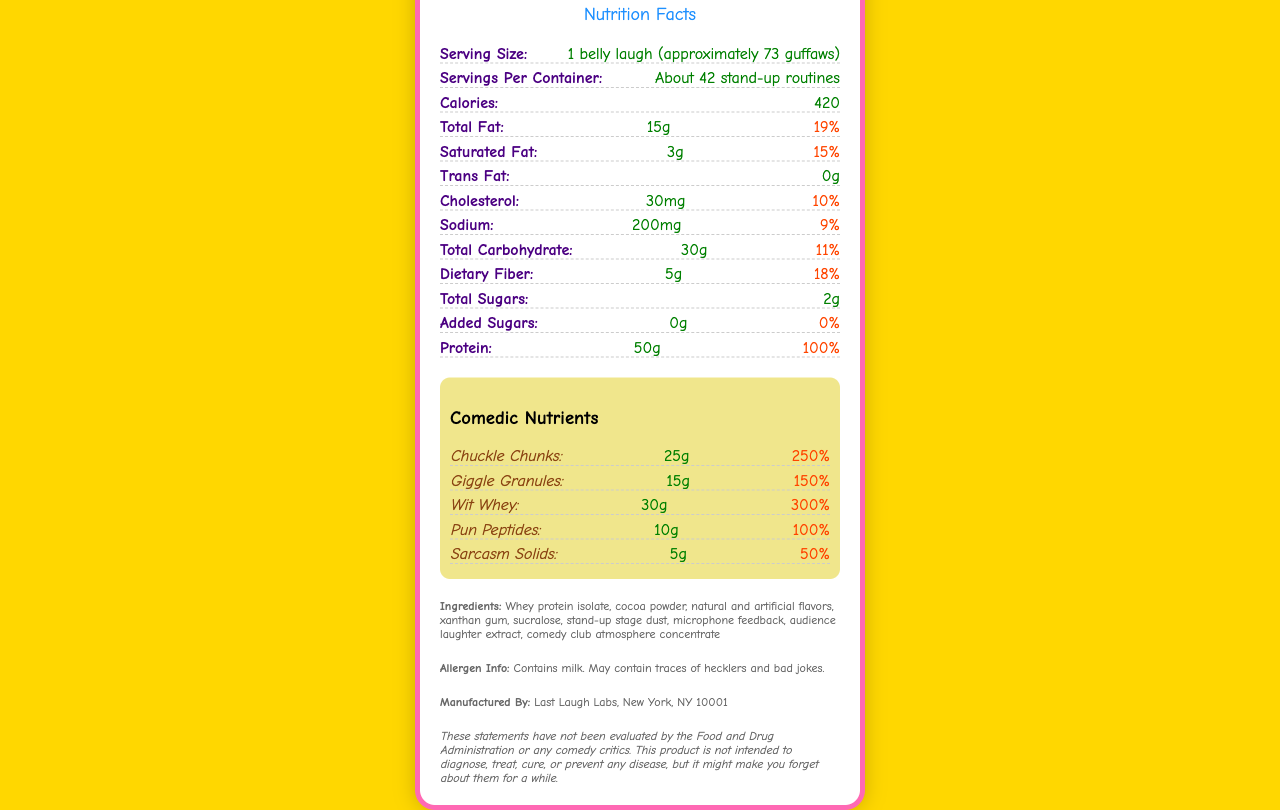What is the serving size for Punchline Protein Powder? The serving size is listed as "1 belly laugh (approximately 73 guffaws)" under the "Serving Size" section of the document.
Answer: 1 belly laugh (approximately 73 guffaws) How many stand-up routines are equivalent to one container of Punchline Protein Powder? According to the "Servings Per Container" section, there are "About 42 stand-up routines" per container.
Answer: About 42 stand-up routines How many calories are in one serving of Punchline Protein Powder? The "Calories" section lists 420 calories per serving.
Answer: 420 calories What is the amount of Chuckle Chunks per serving, and what is its daily value percentage? The "Comedic Nutrients" section specifies 25g of Chuckle Chunks with a daily value of 250%.
Answer: 25g, 250% How much protein does one serving provide? The "Protein" section indicates that one serving provides 50g of protein.
Answer: 50g What is the percentage daily value of iron provided per serving? The document states that the daily value of iron is 45% per serving.
Answer: 45% What allergens are mentioned for Punchline Protein Powder? The "Allergen Info" section indicates that it contains milk and may contain traces of hecklers and bad jokes.
Answer: Contains milk. May contain traces of hecklers and bad jokes. Which of the following is NOT a comedic nutrient found in Punchline Protein Powder? A. Chuckle Chunks B. Wit Whey C. Laugh Loops D. Pun Peptides The "Comedic Nutrients" section lists "Chuckle Chunks," "Wit Whey," and "Pun Peptides," but does not mention "Laugh Loops."
Answer: C. Laugh Loops How many grams of dietary fiber are included in one serving? The "Dietary Fiber" section lists 5 grams per serving.
Answer: 5g What is the percentage daily value of Vitamin D per serving? The information on the percentage daily value for Vitamin D per serving is provided as 10%.
Answer: 10% True or False: Punchline Protein Powder contains added sugars. The document states that the amount of added sugars is 0g, and the daily value is also 0%.
Answer: False Summarize the main idea of the Punchline Protein Powder Nutrition Facts Label. The document details the nutritional information for Punchline Protein Powder, highlighting its comedic branding with unique nutrient names and playful descriptions, while providing essential dietary information and allergen warnings.
Answer: Punchline Protein Powder is a comedic-themed protein supplement with outrageous serving sizes, made-up nutrients, and humorous descriptions. It lists the nutritional content per serving and includes unique comedic nutrients like Chuckle Chunks and Giggle Granules. The label also provides information on allergens, manufacturing details, and a disclaimer about the product's claims. What is the amount of microphone feedback in the Punchline Protein Powder? The document lists microphone feedback as an ingredient but does not provide quantitative information about its amount.
Answer: Cannot be determined 